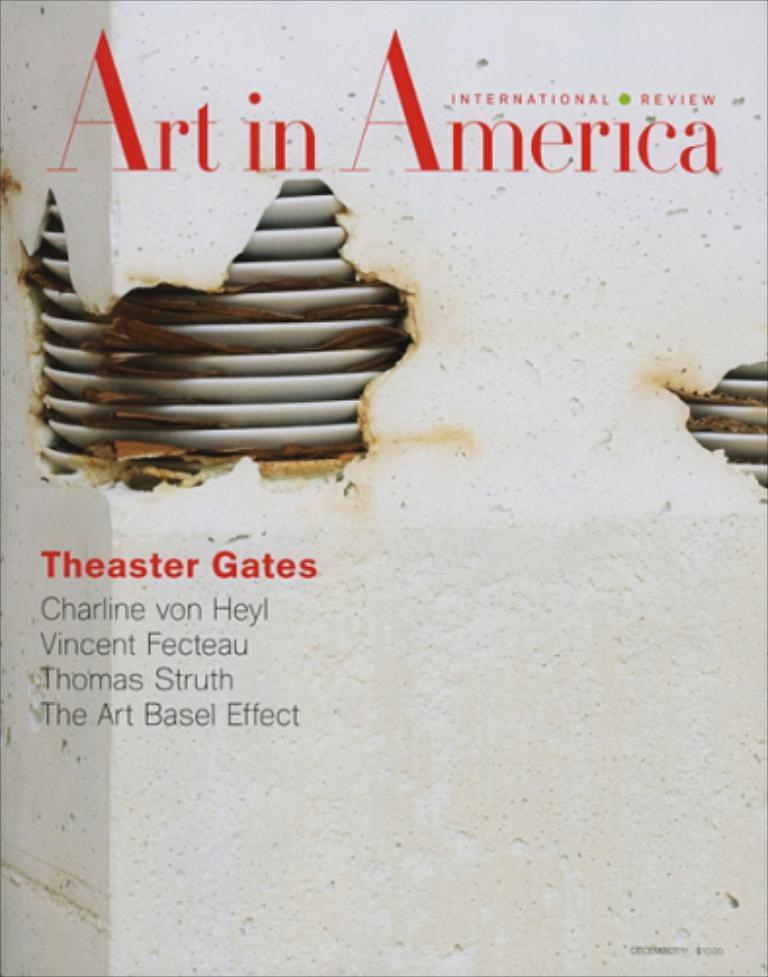Provide a one-sentence caption for the provided image. A white and red print magazine called Art in America. 